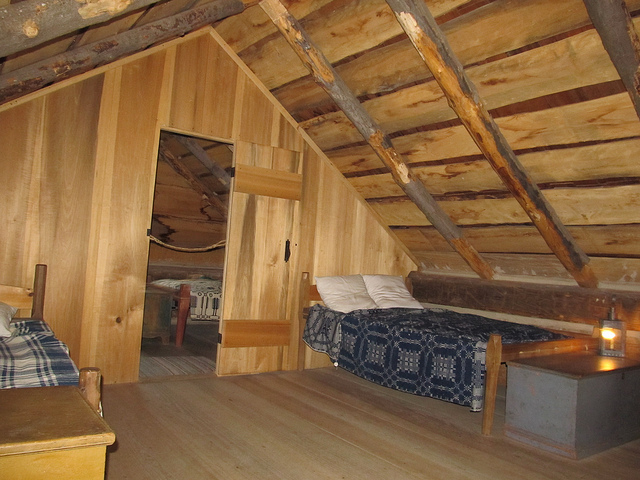What kind of materials are used in the construction of this room? The room showcases a robust construction with exposed wooden beams, which are likely from sturdy trees such as pine or oak, commonly used for their strength and durability. The walls are panelled with a lighter wood, creating a warm and natural ambiance. 